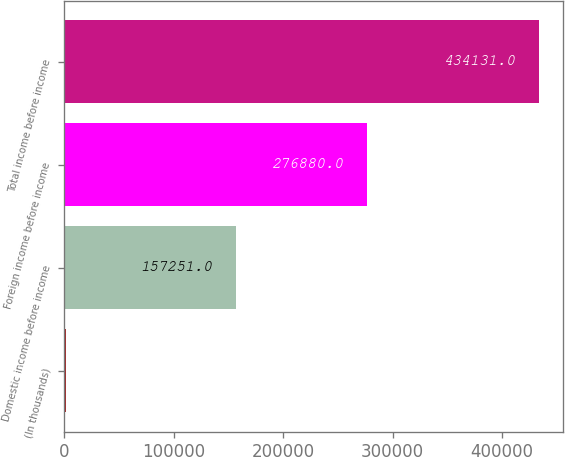Convert chart. <chart><loc_0><loc_0><loc_500><loc_500><bar_chart><fcel>(In thousands)<fcel>Domestic income before income<fcel>Foreign income before income<fcel>Total income before income<nl><fcel>2015<fcel>157251<fcel>276880<fcel>434131<nl></chart> 